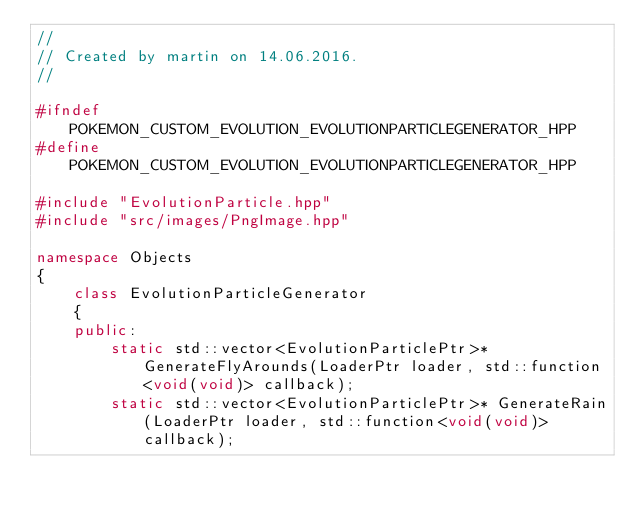Convert code to text. <code><loc_0><loc_0><loc_500><loc_500><_C++_>//
// Created by martin on 14.06.2016.
//

#ifndef POKEMON_CUSTOM_EVOLUTION_EVOLUTIONPARTICLEGENERATOR_HPP
#define POKEMON_CUSTOM_EVOLUTION_EVOLUTIONPARTICLEGENERATOR_HPP

#include "EvolutionParticle.hpp"
#include "src/images/PngImage.hpp"

namespace Objects
{
    class EvolutionParticleGenerator
    {
    public:
        static std::vector<EvolutionParticlePtr>* GenerateFlyArounds(LoaderPtr loader, std::function<void(void)> callback);
        static std::vector<EvolutionParticlePtr>* GenerateRain(LoaderPtr loader, std::function<void(void)> callback);</code> 